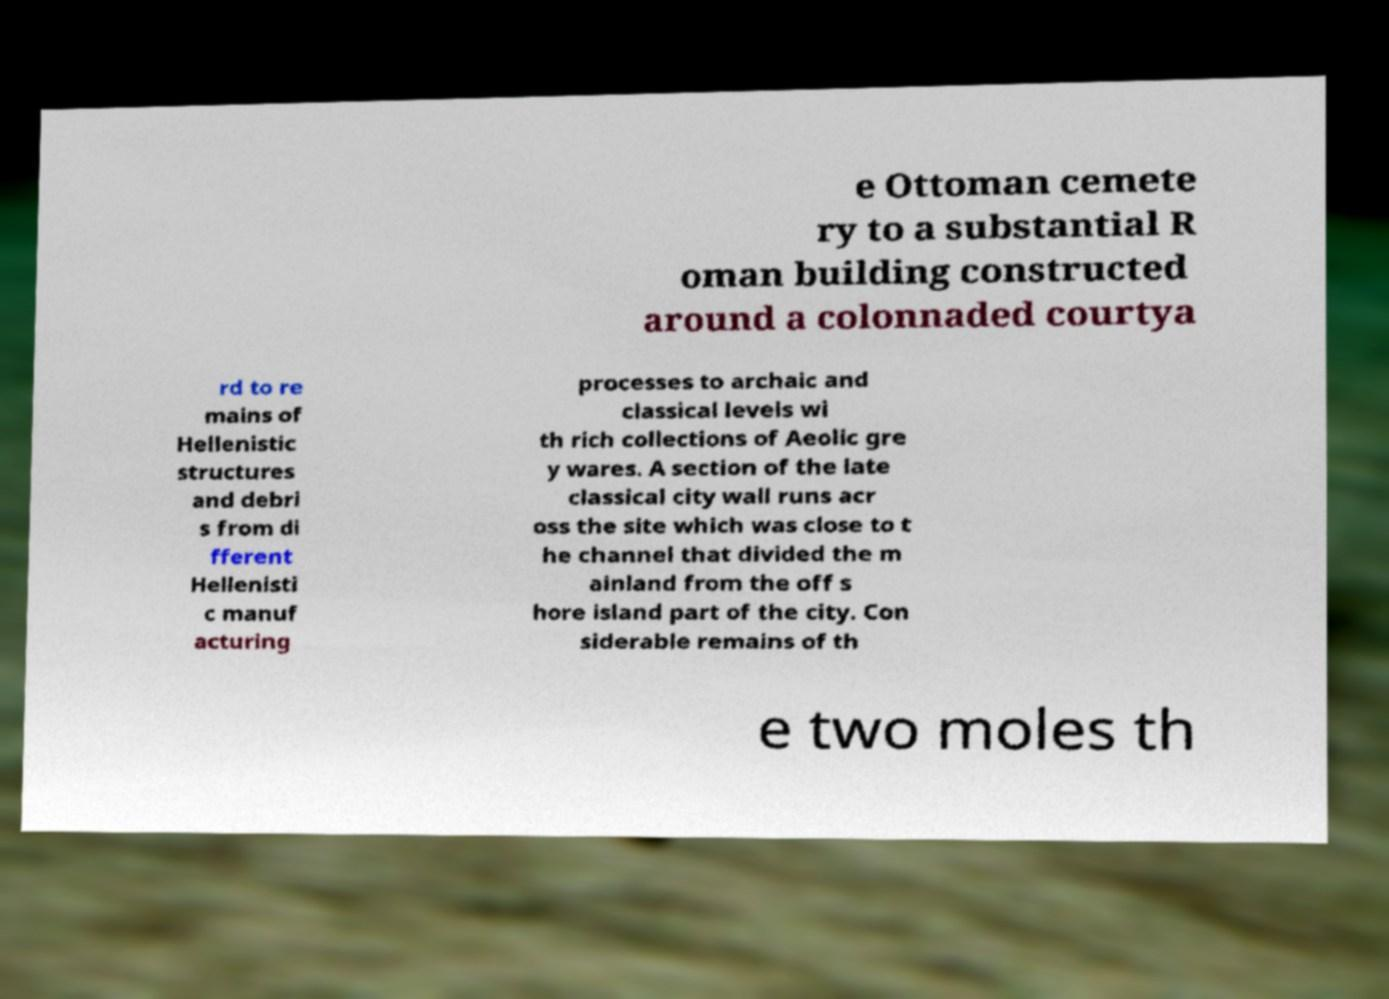Please identify and transcribe the text found in this image. e Ottoman cemete ry to a substantial R oman building constructed around a colonnaded courtya rd to re mains of Hellenistic structures and debri s from di fferent Hellenisti c manuf acturing processes to archaic and classical levels wi th rich collections of Aeolic gre y wares. A section of the late classical city wall runs acr oss the site which was close to t he channel that divided the m ainland from the off s hore island part of the city. Con siderable remains of th e two moles th 